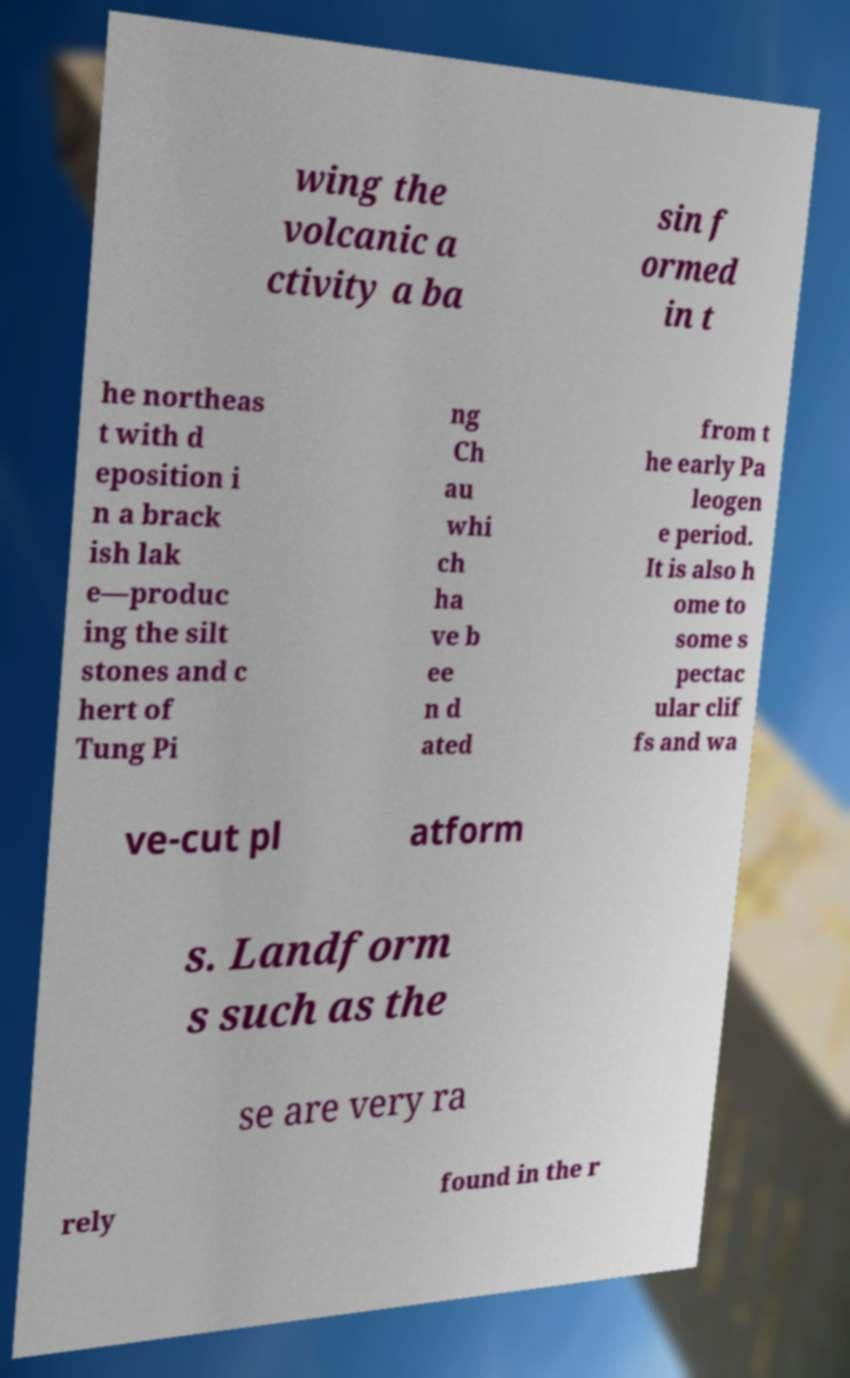I need the written content from this picture converted into text. Can you do that? wing the volcanic a ctivity a ba sin f ormed in t he northeas t with d eposition i n a brack ish lak e—produc ing the silt stones and c hert of Tung Pi ng Ch au whi ch ha ve b ee n d ated from t he early Pa leogen e period. It is also h ome to some s pectac ular clif fs and wa ve-cut pl atform s. Landform s such as the se are very ra rely found in the r 